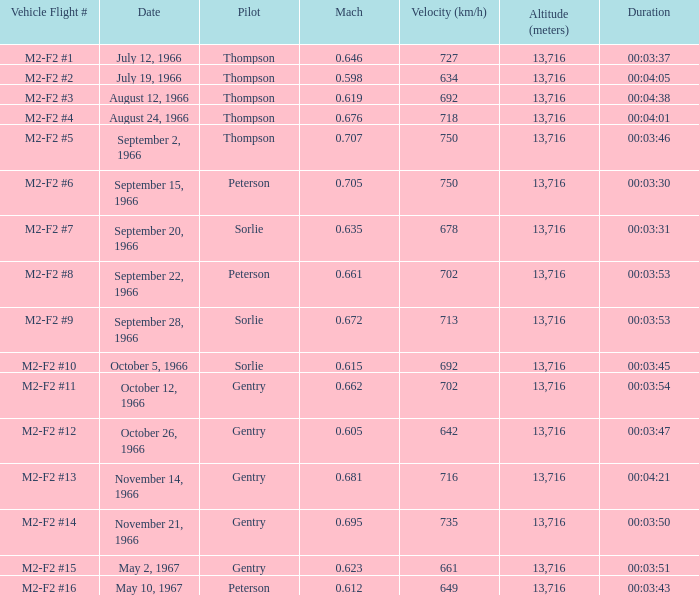What is the Mach with Vehicle Flight # m2-f2 #8 and an Altitude (meters) greater than 13,716? None. 